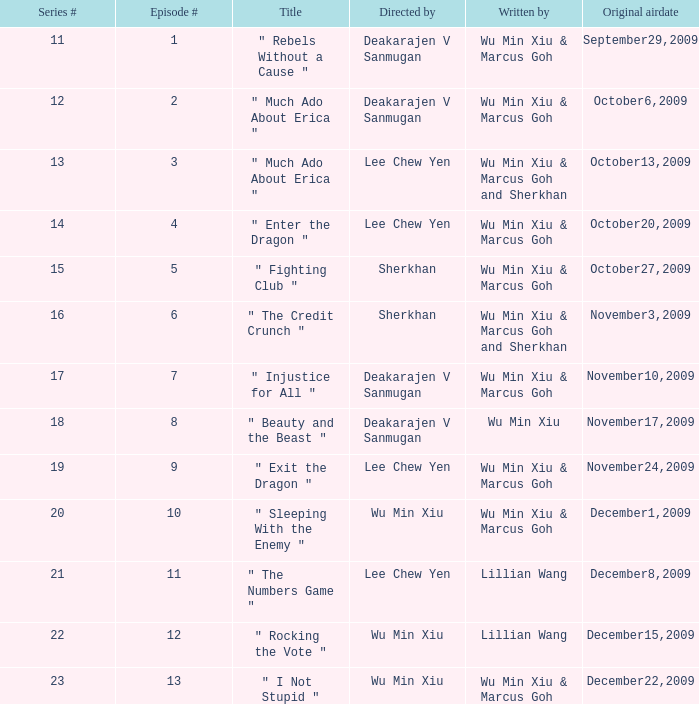What was the title for episode 2? " Much Ado About Erica ". 